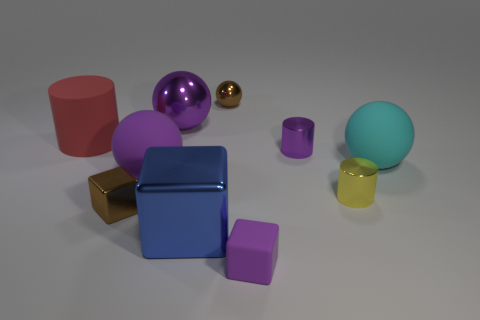Subtract all large spheres. How many spheres are left? 1 Add 1 small cylinders. How many small cylinders are left? 3 Add 3 tiny metal cubes. How many tiny metal cubes exist? 4 Subtract all purple balls. How many balls are left? 2 Subtract 0 blue cylinders. How many objects are left? 10 Subtract all blocks. How many objects are left? 7 Subtract 3 cubes. How many cubes are left? 0 Subtract all blue cylinders. Subtract all green cubes. How many cylinders are left? 3 Subtract all green blocks. How many purple balls are left? 2 Subtract all shiny spheres. Subtract all big metal objects. How many objects are left? 6 